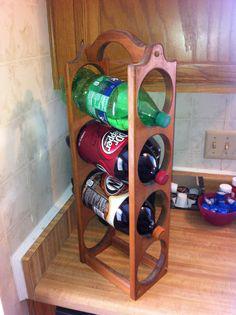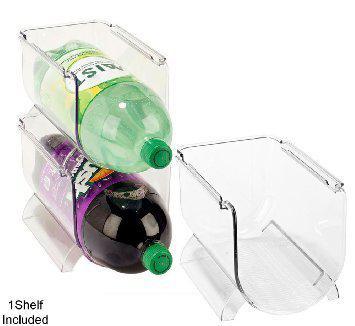The first image is the image on the left, the second image is the image on the right. Examine the images to the left and right. Is the description "There are exactly five bottles of soda." accurate? Answer yes or no. Yes. 